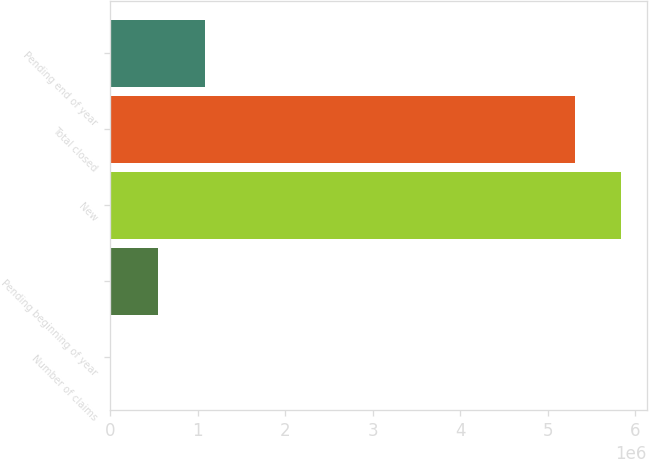<chart> <loc_0><loc_0><loc_500><loc_500><bar_chart><fcel>Number of claims<fcel>Pending beginning of year<fcel>New<fcel>Total closed<fcel>Pending end of year<nl><fcel>2008<fcel>551598<fcel>5.84038e+06<fcel>5.30828e+06<fcel>1.0837e+06<nl></chart> 